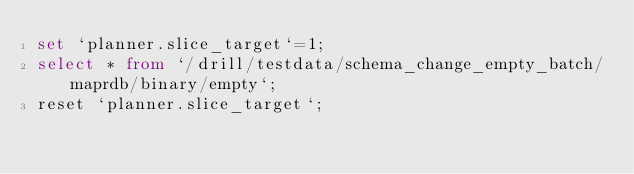Convert code to text. <code><loc_0><loc_0><loc_500><loc_500><_SQL_>set `planner.slice_target`=1;
select * from `/drill/testdata/schema_change_empty_batch/maprdb/binary/empty`;
reset `planner.slice_target`;
</code> 